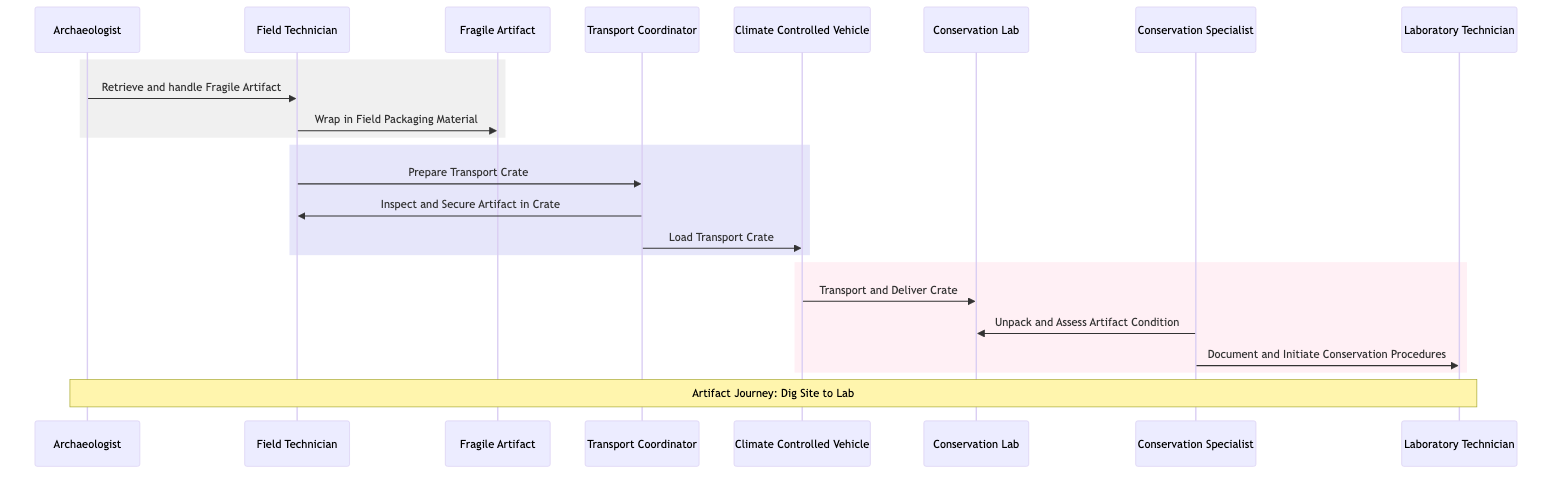What is the first action in the workflow? The first action is performed by the Archaeologist, who instructs the Field Technician to retrieve and handle the Fragile Artifact. This is the starting point of the sequence.
Answer: Retrieve and handle Fragile Artifact Who wraps the Fragile Artifact? The wrapping of the Fragile Artifact is done by the Field Technician, as indicated by the message directed from the Field Technician to the Fragile Artifact.
Answer: Field Technician How many actors are involved in this sequence diagram? There are five actors depicted in the sequence: Archaeologist, Field Technician, Transport Coordinator, Conservation Specialist, and Laboratory Technician. I counted each unique actor present in the diagram.
Answer: Five What does the Transport Coordinator do after preparing the Transport Crate? After preparing the Transport Crate, the Transport Coordinator inspects and secures the artifact in the crate, as demonstrated by the message from the coordinator to the Field Technician.
Answer: Inspect and Secure Artifact in Crate What type of vehicle is used to transport the artifacts? The vehicle used for transport is a Climate Controlled Vehicle, which ensures that the artifacts are maintained under suitable conditions throughout the transportation process.
Answer: Climate Controlled Vehicle What action follows the transport of the crate to the Conservation Lab? After arriving at the Conservation Lab, the Conservation Specialist unpacks and assesses the condition of the artifact, which is the subsequent step following transport.
Answer: Unpack and Assess Artifact Condition What is documented by the Conservation Specialist? The Conservation Specialist documents and initiates conservation procedures related to the artifact after assessing its condition, as noted from the message to the Laboratory Technician.
Answer: Document and Initiate Conservation Procedures Which actor is responsible for loading the Transport Crate? The responsibility of loading the Transport Crate falls to the Transport Coordinator, who is in charge of this logistic process as the flow indicates.
Answer: Transport Coordinator What marks the end of the artifact's journey depicted in the diagram? The end of the artifact's journey is marked by the delivery of the crate to the Conservation Lab, which signifies the successful completion of the transport phase.
Answer: Delivery to Conservation Lab 